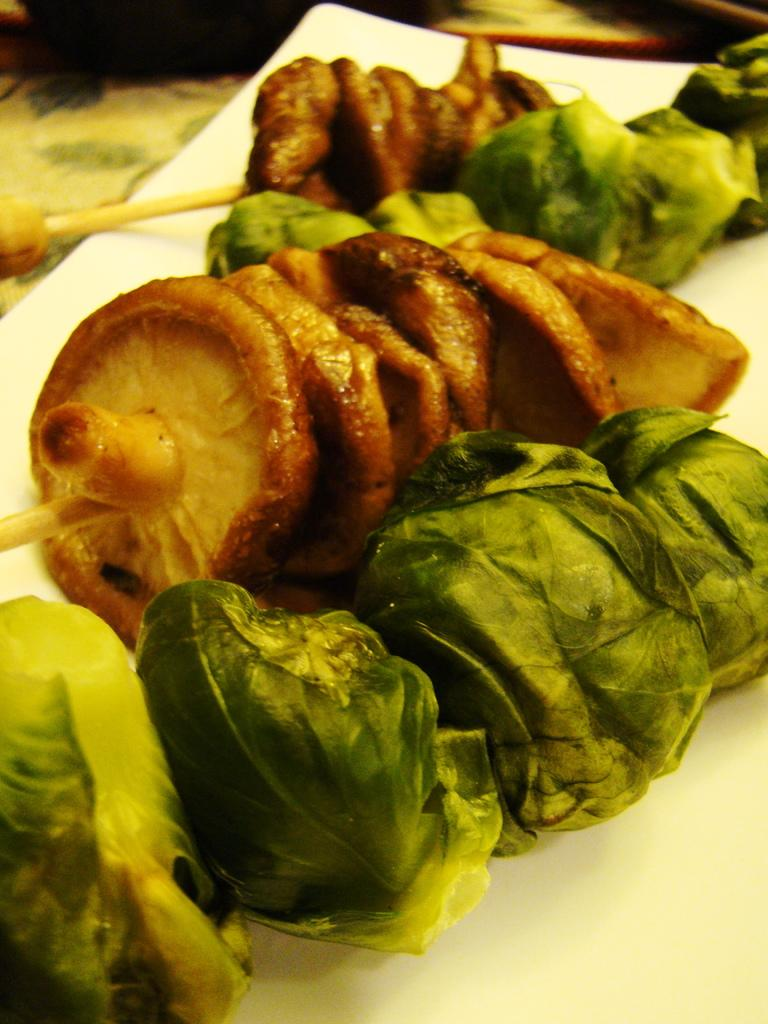What type of food items are present in the image? There are mushrooms and leafy vegetables in the image. How are the mushrooms and leafy vegetables arranged in the image? The mushrooms and leafy vegetables are on a white plate. How does the snow affect the growth of the mushrooms in the image? There is no snow present in the image, so its effect on the mushrooms cannot be determined. 